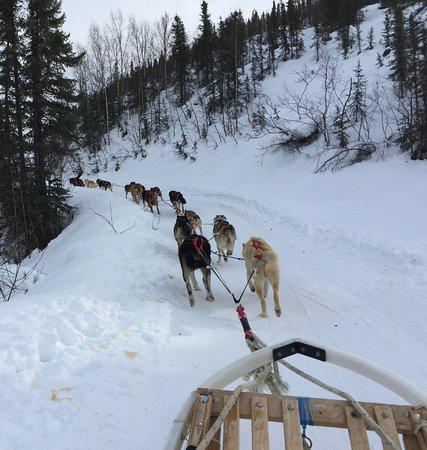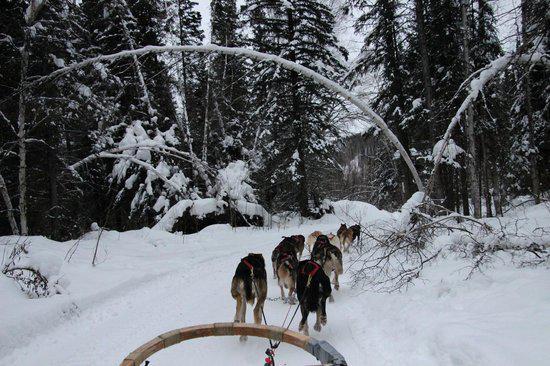The first image is the image on the left, the second image is the image on the right. Considering the images on both sides, is "In one image, sled dogs are standing at their base camp, and in the second image, they are running to pull a sled for a driver." valid? Answer yes or no. No. The first image is the image on the left, the second image is the image on the right. Examine the images to the left and right. Is the description "One image shows a dog team running forward toward the right, and the other image includes box-shaped doghouses along the horizon in front of evergreens and tall hills." accurate? Answer yes or no. No. 